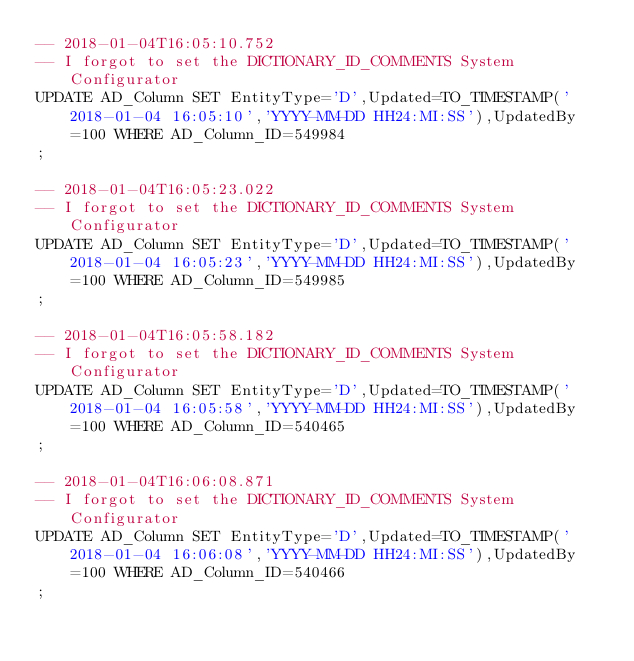Convert code to text. <code><loc_0><loc_0><loc_500><loc_500><_SQL_>-- 2018-01-04T16:05:10.752
-- I forgot to set the DICTIONARY_ID_COMMENTS System Configurator
UPDATE AD_Column SET EntityType='D',Updated=TO_TIMESTAMP('2018-01-04 16:05:10','YYYY-MM-DD HH24:MI:SS'),UpdatedBy=100 WHERE AD_Column_ID=549984
;

-- 2018-01-04T16:05:23.022
-- I forgot to set the DICTIONARY_ID_COMMENTS System Configurator
UPDATE AD_Column SET EntityType='D',Updated=TO_TIMESTAMP('2018-01-04 16:05:23','YYYY-MM-DD HH24:MI:SS'),UpdatedBy=100 WHERE AD_Column_ID=549985
;

-- 2018-01-04T16:05:58.182
-- I forgot to set the DICTIONARY_ID_COMMENTS System Configurator
UPDATE AD_Column SET EntityType='D',Updated=TO_TIMESTAMP('2018-01-04 16:05:58','YYYY-MM-DD HH24:MI:SS'),UpdatedBy=100 WHERE AD_Column_ID=540465
;

-- 2018-01-04T16:06:08.871
-- I forgot to set the DICTIONARY_ID_COMMENTS System Configurator
UPDATE AD_Column SET EntityType='D',Updated=TO_TIMESTAMP('2018-01-04 16:06:08','YYYY-MM-DD HH24:MI:SS'),UpdatedBy=100 WHERE AD_Column_ID=540466
;

</code> 